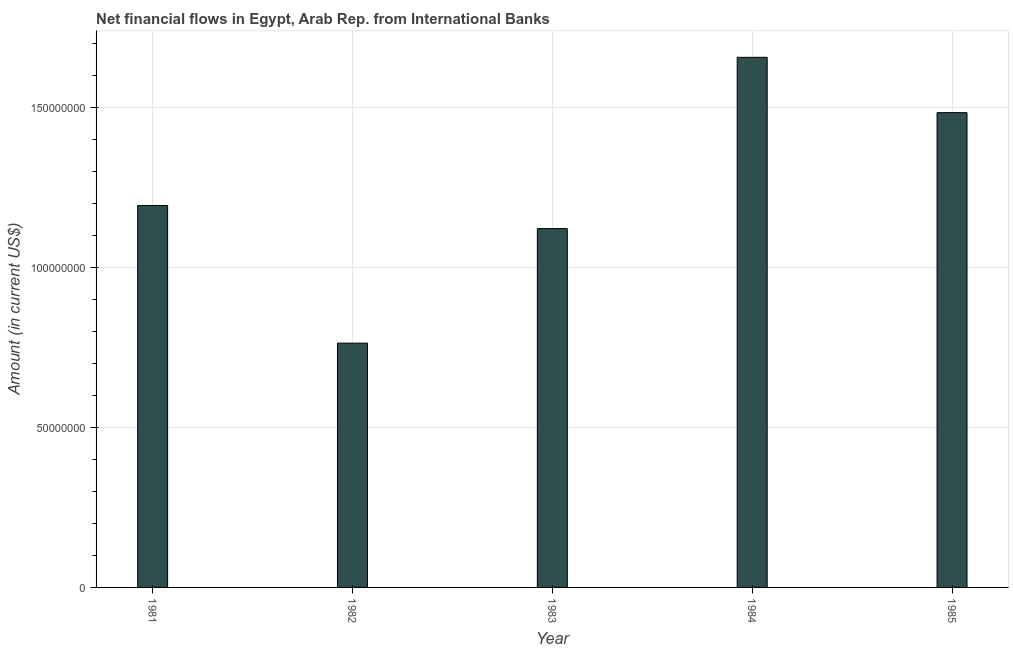Does the graph contain any zero values?
Your response must be concise. No. What is the title of the graph?
Provide a short and direct response. Net financial flows in Egypt, Arab Rep. from International Banks. What is the label or title of the X-axis?
Provide a short and direct response. Year. What is the label or title of the Y-axis?
Your answer should be very brief. Amount (in current US$). What is the net financial flows from ibrd in 1984?
Your answer should be compact. 1.66e+08. Across all years, what is the maximum net financial flows from ibrd?
Your answer should be compact. 1.66e+08. Across all years, what is the minimum net financial flows from ibrd?
Provide a short and direct response. 7.63e+07. What is the sum of the net financial flows from ibrd?
Your answer should be compact. 6.22e+08. What is the difference between the net financial flows from ibrd in 1982 and 1985?
Offer a very short reply. -7.20e+07. What is the average net financial flows from ibrd per year?
Offer a terse response. 1.24e+08. What is the median net financial flows from ibrd?
Your answer should be compact. 1.19e+08. In how many years, is the net financial flows from ibrd greater than 150000000 US$?
Your answer should be compact. 1. What is the ratio of the net financial flows from ibrd in 1982 to that in 1984?
Offer a terse response. 0.46. Is the net financial flows from ibrd in 1982 less than that in 1984?
Give a very brief answer. Yes. What is the difference between the highest and the second highest net financial flows from ibrd?
Your response must be concise. 1.73e+07. Is the sum of the net financial flows from ibrd in 1982 and 1984 greater than the maximum net financial flows from ibrd across all years?
Ensure brevity in your answer.  Yes. What is the difference between the highest and the lowest net financial flows from ibrd?
Offer a terse response. 8.93e+07. How many bars are there?
Offer a very short reply. 5. What is the difference between two consecutive major ticks on the Y-axis?
Provide a short and direct response. 5.00e+07. Are the values on the major ticks of Y-axis written in scientific E-notation?
Give a very brief answer. No. What is the Amount (in current US$) of 1981?
Ensure brevity in your answer.  1.19e+08. What is the Amount (in current US$) of 1982?
Your answer should be very brief. 7.63e+07. What is the Amount (in current US$) in 1983?
Offer a terse response. 1.12e+08. What is the Amount (in current US$) in 1984?
Keep it short and to the point. 1.66e+08. What is the Amount (in current US$) of 1985?
Make the answer very short. 1.48e+08. What is the difference between the Amount (in current US$) in 1981 and 1982?
Provide a short and direct response. 4.30e+07. What is the difference between the Amount (in current US$) in 1981 and 1983?
Ensure brevity in your answer.  7.20e+06. What is the difference between the Amount (in current US$) in 1981 and 1984?
Offer a very short reply. -4.63e+07. What is the difference between the Amount (in current US$) in 1981 and 1985?
Offer a very short reply. -2.90e+07. What is the difference between the Amount (in current US$) in 1982 and 1983?
Provide a succinct answer. -3.58e+07. What is the difference between the Amount (in current US$) in 1982 and 1984?
Offer a very short reply. -8.93e+07. What is the difference between the Amount (in current US$) in 1982 and 1985?
Offer a very short reply. -7.20e+07. What is the difference between the Amount (in current US$) in 1983 and 1984?
Your response must be concise. -5.35e+07. What is the difference between the Amount (in current US$) in 1983 and 1985?
Your answer should be very brief. -3.62e+07. What is the difference between the Amount (in current US$) in 1984 and 1985?
Offer a terse response. 1.73e+07. What is the ratio of the Amount (in current US$) in 1981 to that in 1982?
Offer a terse response. 1.56. What is the ratio of the Amount (in current US$) in 1981 to that in 1983?
Provide a succinct answer. 1.06. What is the ratio of the Amount (in current US$) in 1981 to that in 1984?
Your answer should be compact. 0.72. What is the ratio of the Amount (in current US$) in 1981 to that in 1985?
Offer a very short reply. 0.8. What is the ratio of the Amount (in current US$) in 1982 to that in 1983?
Your answer should be compact. 0.68. What is the ratio of the Amount (in current US$) in 1982 to that in 1984?
Keep it short and to the point. 0.46. What is the ratio of the Amount (in current US$) in 1982 to that in 1985?
Provide a succinct answer. 0.52. What is the ratio of the Amount (in current US$) in 1983 to that in 1984?
Provide a succinct answer. 0.68. What is the ratio of the Amount (in current US$) in 1983 to that in 1985?
Provide a succinct answer. 0.76. What is the ratio of the Amount (in current US$) in 1984 to that in 1985?
Offer a very short reply. 1.12. 